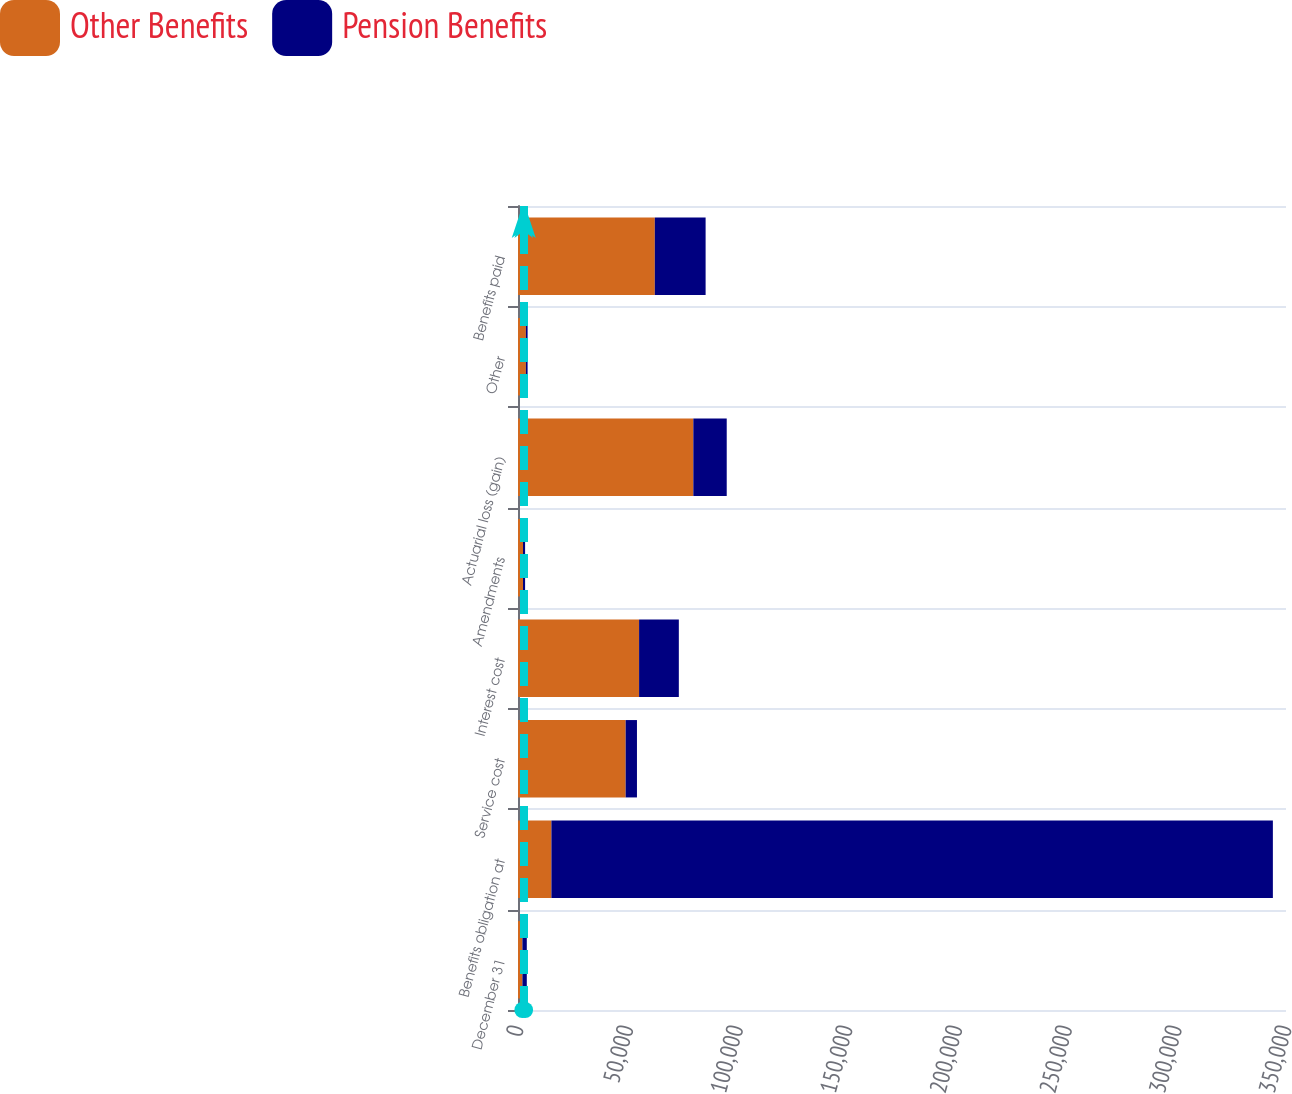Convert chart to OTSL. <chart><loc_0><loc_0><loc_500><loc_500><stacked_bar_chart><ecel><fcel>December 31<fcel>Benefits obligation at<fcel>Service cost<fcel>Interest cost<fcel>Amendments<fcel>Actuarial loss (gain)<fcel>Other<fcel>Benefits paid<nl><fcel>Other Benefits<fcel>2005<fcel>15221<fcel>49065<fcel>55181<fcel>2275<fcel>79903<fcel>3598<fcel>62352<nl><fcel>Pension Benefits<fcel>2005<fcel>328799<fcel>5149<fcel>18115<fcel>960<fcel>15221<fcel>780<fcel>23148<nl></chart> 